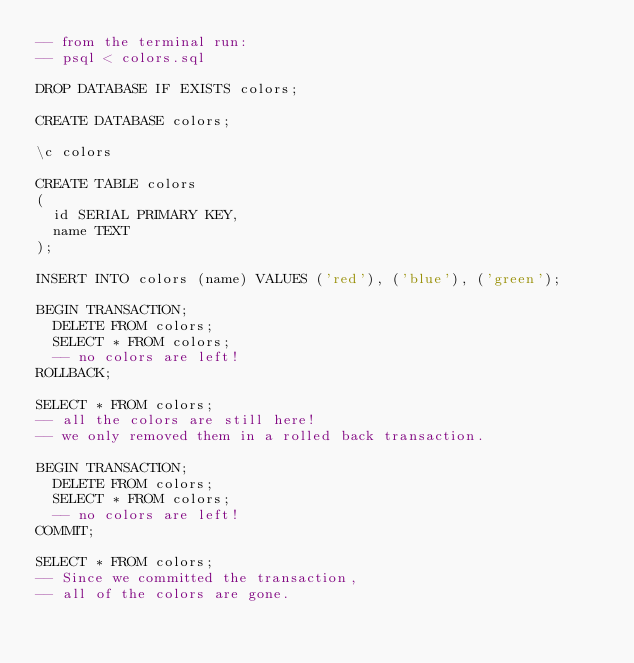Convert code to text. <code><loc_0><loc_0><loc_500><loc_500><_SQL_>-- from the terminal run:
-- psql < colors.sql

DROP DATABASE IF EXISTS colors;

CREATE DATABASE colors;

\c colors

CREATE TABLE colors
(
  id SERIAL PRIMARY KEY,
  name TEXT
);

INSERT INTO colors (name) VALUES ('red'), ('blue'), ('green');

BEGIN TRANSACTION;
  DELETE FROM colors;
  SELECT * FROM colors; 
  -- no colors are left!
ROLLBACK;

SELECT * FROM colors;
-- all the colors are still here!
-- we only removed them in a rolled back transaction.

BEGIN TRANSACTION;
  DELETE FROM colors;
  SELECT * FROM colors; 
  -- no colors are left!
COMMIT;

SELECT * FROM colors;
-- Since we committed the transaction,
-- all of the colors are gone.</code> 